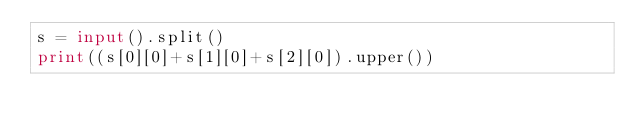<code> <loc_0><loc_0><loc_500><loc_500><_Python_>s = input().split()
print((s[0][0]+s[1][0]+s[2][0]).upper())</code> 